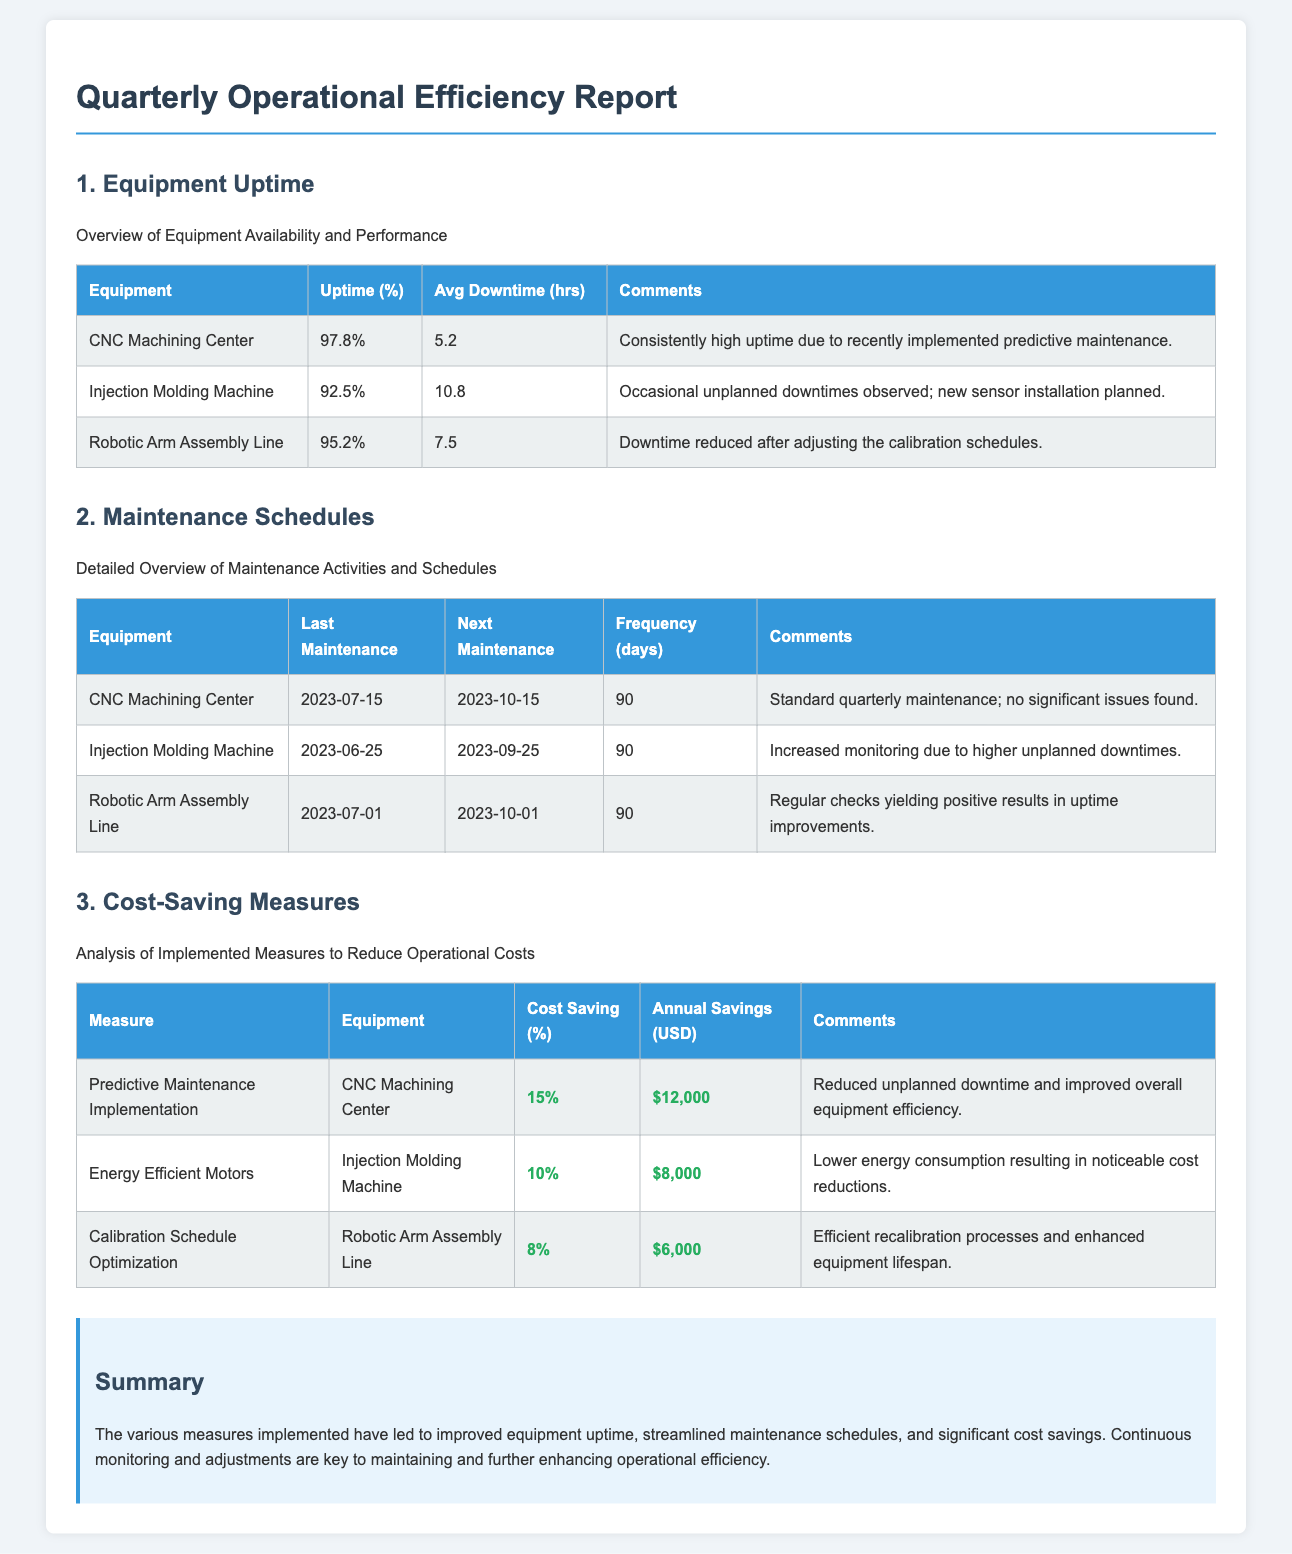What is the uptime percentage for the CNC Machining Center? The uptime percentage for the CNC Machining Center is stated in the document as 97.8%.
Answer: 97.8% What is the average downtime in hours for the Injection Molding Machine? The average downtime for the Injection Molding Machine is provided as 10.8 hours.
Answer: 10.8 What was the last maintenance date for the Robotic Arm Assembly Line? The last maintenance date for the Robotic Arm Assembly Line is mentioned as July 1, 2023.
Answer: 2023-07-01 What is the cost saving percentage for the Predictive Maintenance Implementation on the CNC Machining Center? The cost saving percentage is listed as 15%.
Answer: 15% How much annual savings does the implementation of energy-efficient motors yield for the Injection Molding Machine? The document states that the annual savings from energy-efficient motors is $8,000.
Answer: $8,000 What is the frequency of the maintenance schedule for the equipment listed? All equipment in the document has a maintenance frequency of 90 days.
Answer: 90 Which equipment had its downtime reduced after adjusting calibration schedules? The document specifies that the Robotic Arm Assembly Line had its downtime reduced after these adjustments.
Answer: Robotic Arm Assembly Line What is the primary benefit of the predictive maintenance implemented for the CNC Machining Center? The document highlights that the primary benefit is reduced unplanned downtime and improved overall equipment efficiency.
Answer: Reduced unplanned downtime What is the total annual savings reported in the cost-saving measures section? By adding the annual savings from each measure ($12,000 + $8,000 + $6,000) the total amounts to $26,000.
Answer: $26,000 